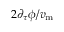<formula> <loc_0><loc_0><loc_500><loc_500>{ { 2 \partial _ { \tau } \phi } / { v _ { m } } }</formula> 